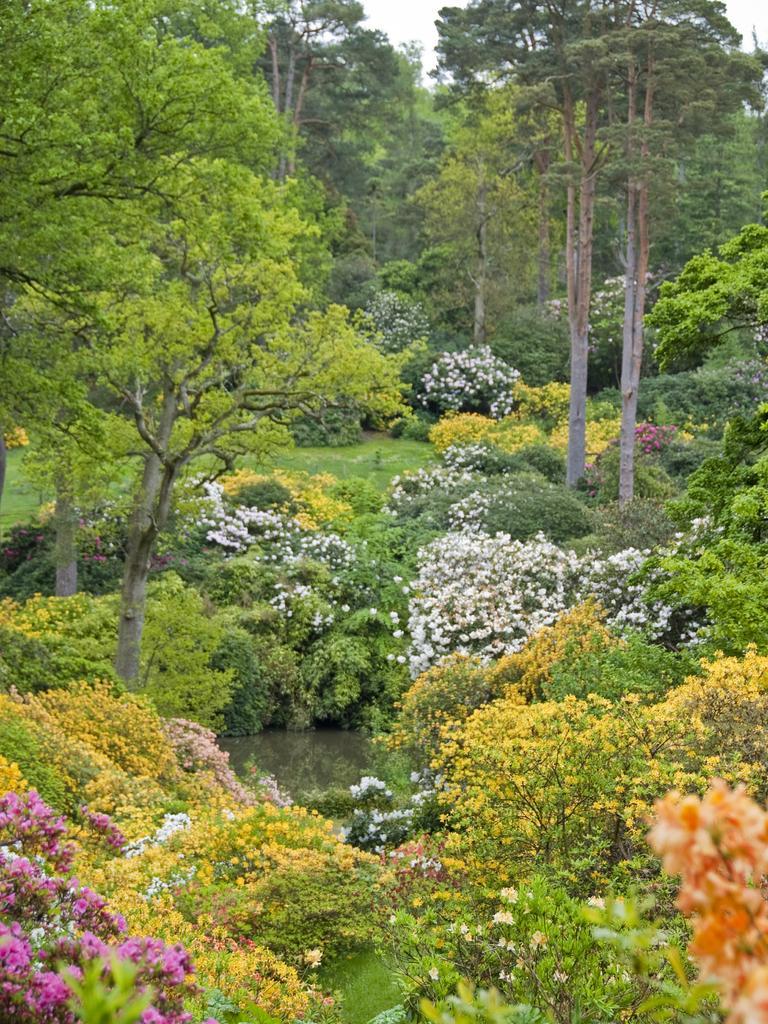Could you give a brief overview of what you see in this image? In this image we can see few plants, trees, water between the plants and the sky in the background. 